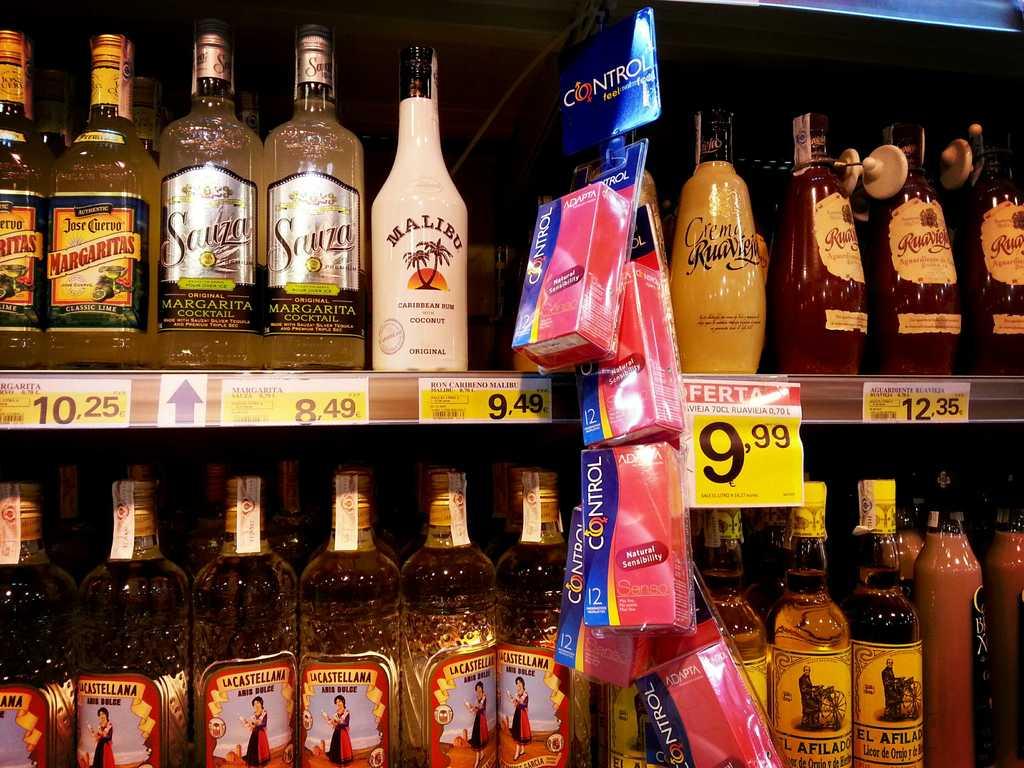How much does the jose cuervo margarita cost?
Provide a short and direct response. 10.25. 